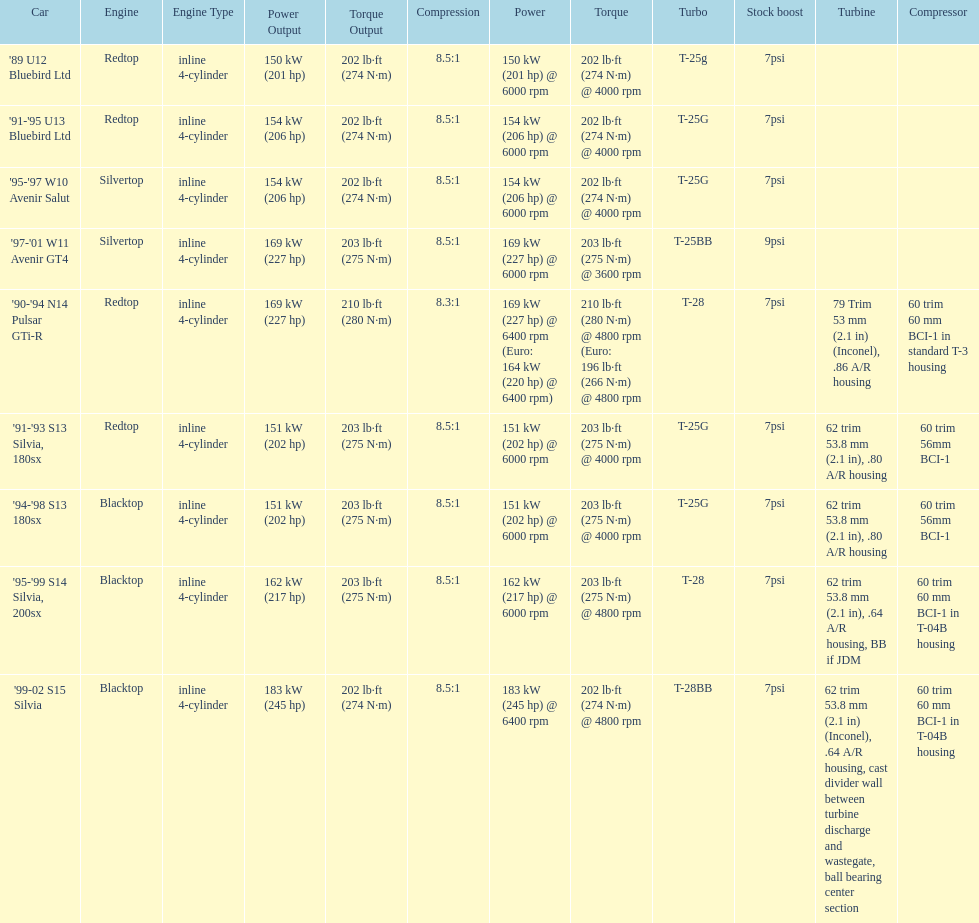Which engine has the smallest compression rate? '90-'94 N14 Pulsar GTi-R. 